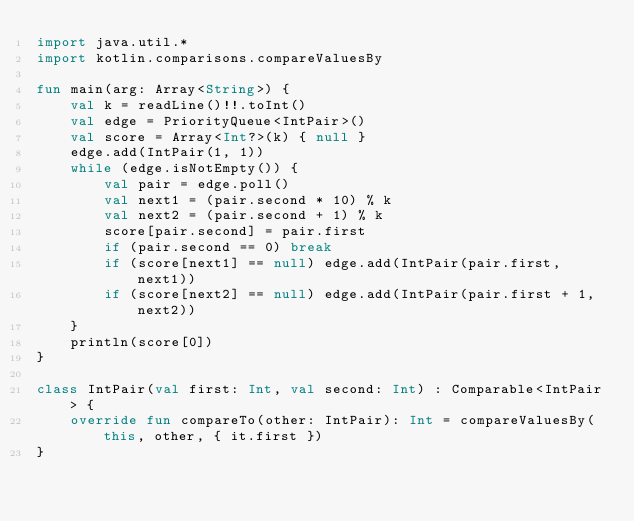Convert code to text. <code><loc_0><loc_0><loc_500><loc_500><_Kotlin_>import java.util.*
import kotlin.comparisons.compareValuesBy

fun main(arg: Array<String>) {
    val k = readLine()!!.toInt()
    val edge = PriorityQueue<IntPair>()
    val score = Array<Int?>(k) { null }
    edge.add(IntPair(1, 1))
    while (edge.isNotEmpty()) {
        val pair = edge.poll()
        val next1 = (pair.second * 10) % k
        val next2 = (pair.second + 1) % k
        score[pair.second] = pair.first
        if (pair.second == 0) break
        if (score[next1] == null) edge.add(IntPair(pair.first, next1))
        if (score[next2] == null) edge.add(IntPair(pair.first + 1, next2))
    }
    println(score[0])
}

class IntPair(val first: Int, val second: Int) : Comparable<IntPair> {
    override fun compareTo(other: IntPair): Int = compareValuesBy(this, other, { it.first })
}
</code> 